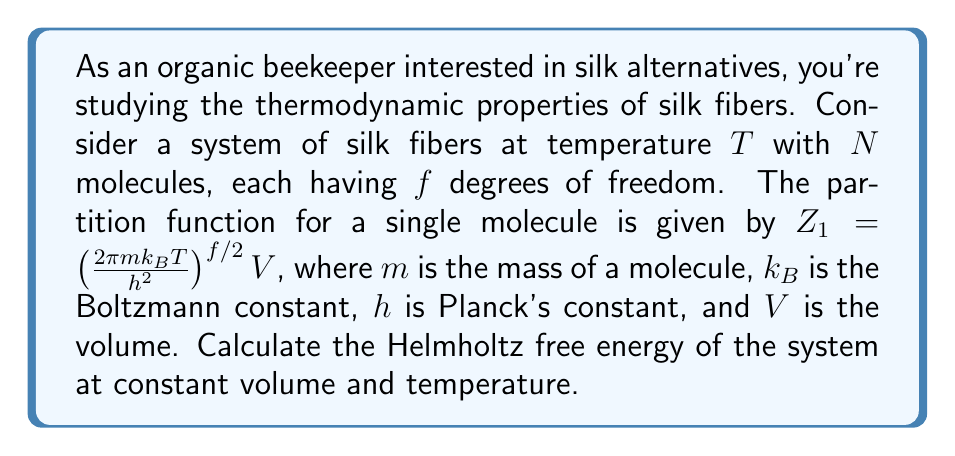What is the answer to this math problem? To solve this problem, we'll follow these steps:

1) The partition function for the entire system of N identical, non-interacting molecules is:

   $$Z = (Z_1)^N = \left[\left(\frac{2\pi mk_BT}{h^2}\right)^{f/2}V\right]^N$$

2) The Helmholtz free energy $F$ is related to the partition function $Z$ by:

   $$F = -k_BT \ln Z$$

3) Substituting the expression for $Z$:

   $$F = -k_BT \ln \left[\left(\frac{2\pi mk_BT}{h^2}\right)^{f/2}V\right]^N$$

4) Using the properties of logarithms:

   $$F = -Nk_BT \ln \left[\left(\frac{2\pi mk_BT}{h^2}\right)^{f/2}V\right]$$

5) Expanding the logarithm:

   $$F = -Nk_BT \left[\frac{f}{2}\ln\left(\frac{2\pi mk_BT}{h^2}\right) + \ln V\right]$$

6) Rearranging terms:

   $$F = -\frac{Nfk_BT}{2}\ln\left(\frac{2\pi mk_BT}{h^2}\right) - Nk_BT\ln V$$

This is the final expression for the Helmholtz free energy of the silk fiber system under the given conditions.
Answer: $$F = -\frac{Nfk_BT}{2}\ln\left(\frac{2\pi mk_BT}{h^2}\right) - Nk_BT\ln V$$ 